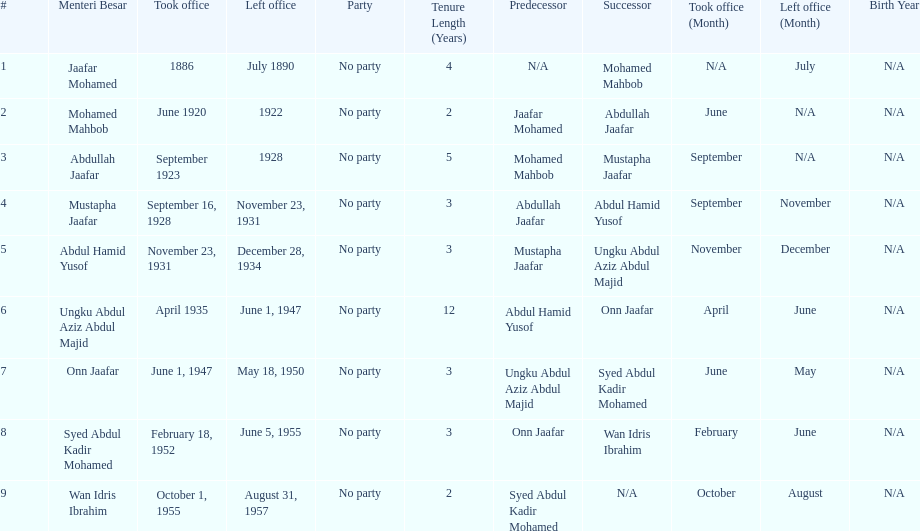Name someone who was not in office more than 4 years. Mohamed Mahbob. 